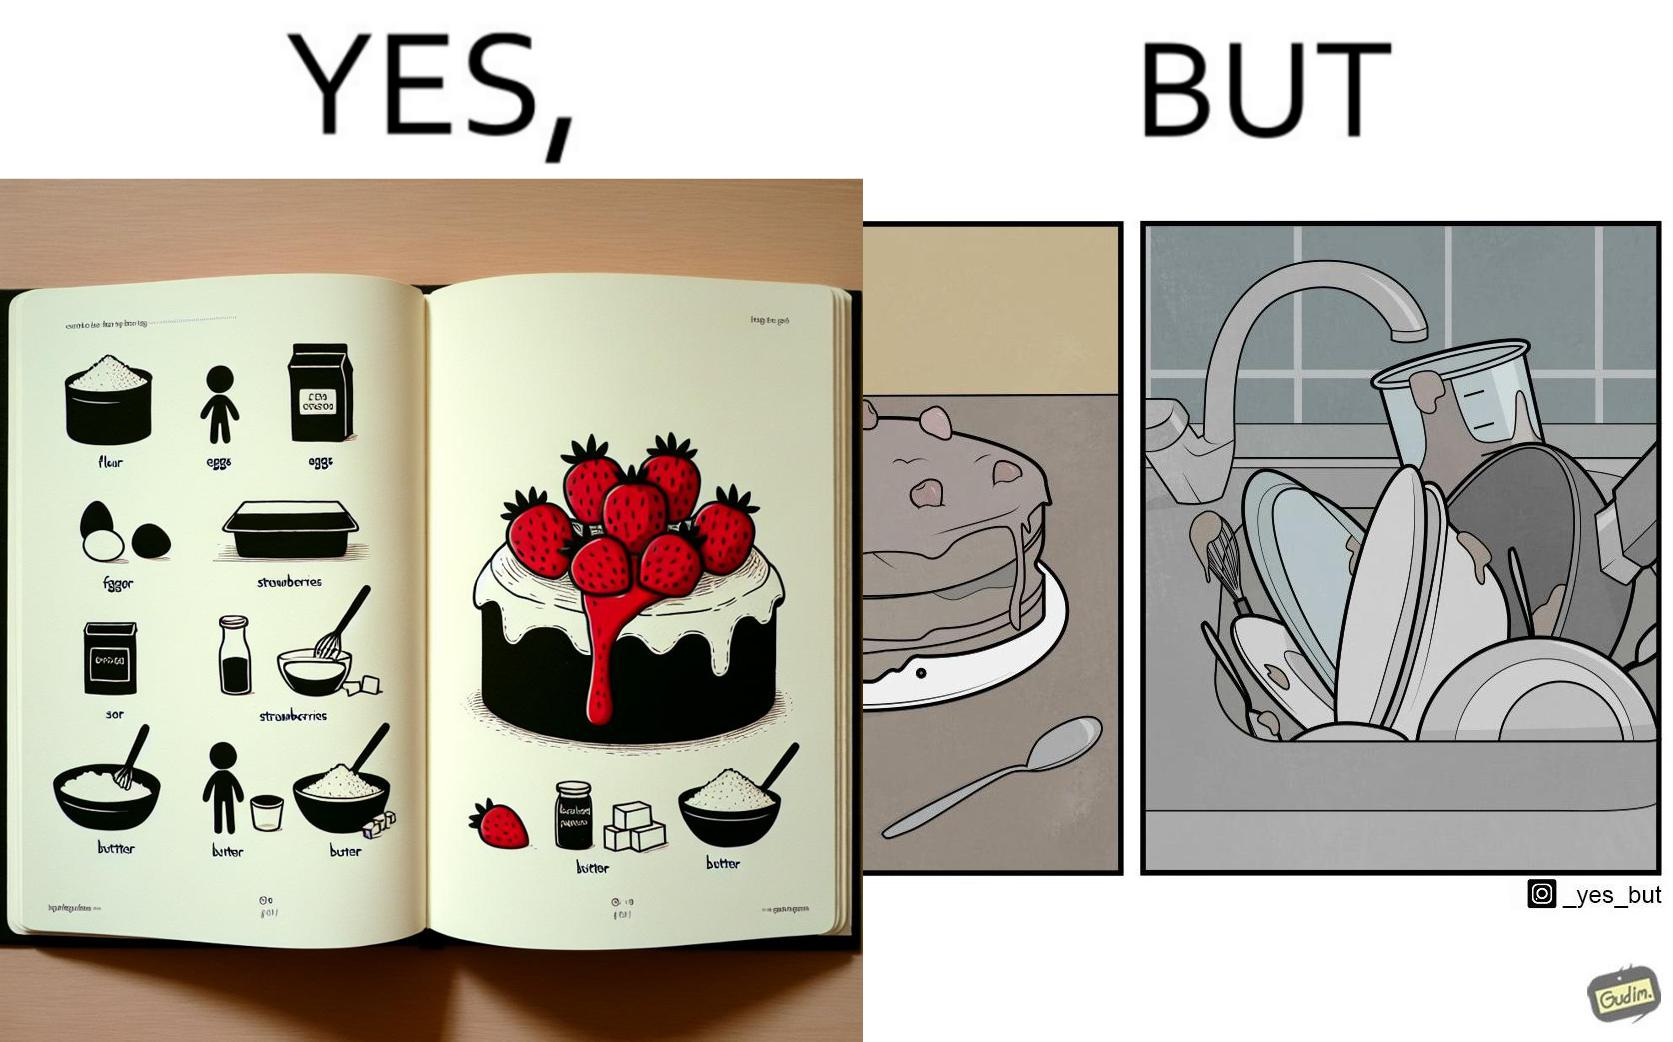What do you see in each half of this image? In the left part of the image: a page of a book showing the image of a strawberry cake, along with its ingredients. In the right part of the image: a cake on a plate, along with a bunch of used utensils to be washed. 